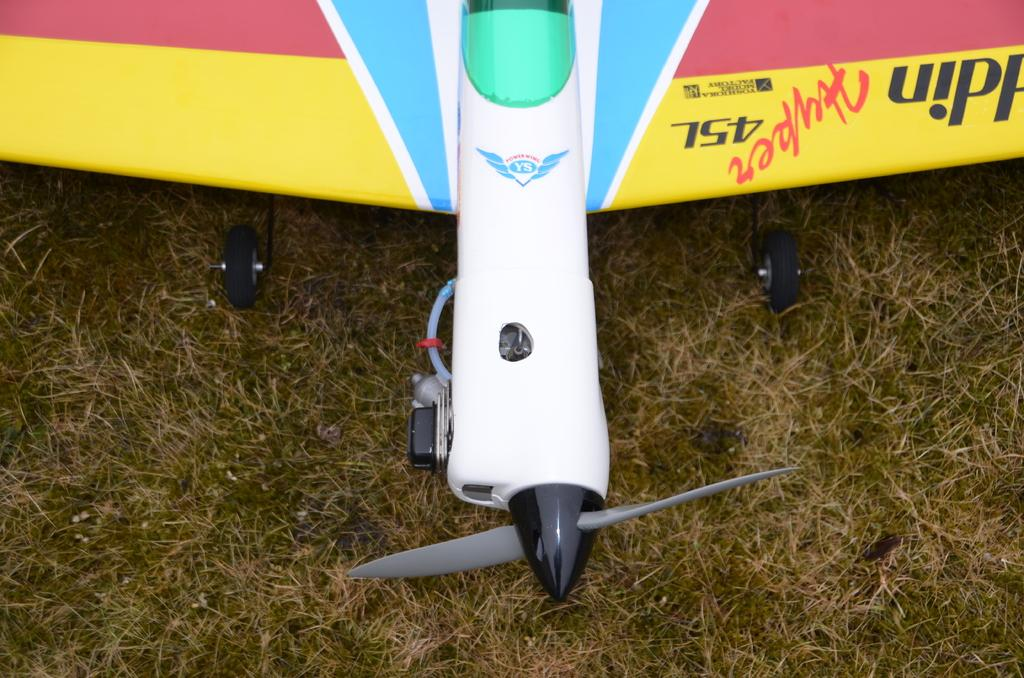What is the main subject of the image? The main subject of the image is an aircraft. Where is the aircraft located in the image? The aircraft is on the grass in the image. Is there any text or writing on the aircraft? Yes, there is writing on the aircraft. What type of stitch is used to sew the aircraft's wings together in the image? There is no stitching or sewing involved in the construction of the aircraft in the image. 